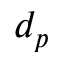Convert formula to latex. <formula><loc_0><loc_0><loc_500><loc_500>d _ { p }</formula> 